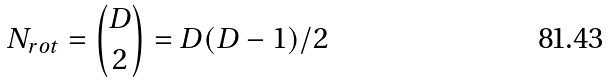<formula> <loc_0><loc_0><loc_500><loc_500>N _ { r o t } = { \binom { D } { 2 } } = D ( D - 1 ) / 2</formula> 